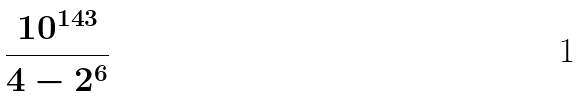<formula> <loc_0><loc_0><loc_500><loc_500>\frac { 1 0 ^ { 1 4 3 } } { 4 - 2 ^ { 6 } }</formula> 